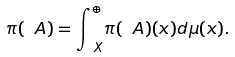<formula> <loc_0><loc_0><loc_500><loc_500>\pi ( \ A ) = { \int } _ { \, X } ^ { \oplus } \pi ( \ A ) ( x ) d \mu ( x ) .</formula> 